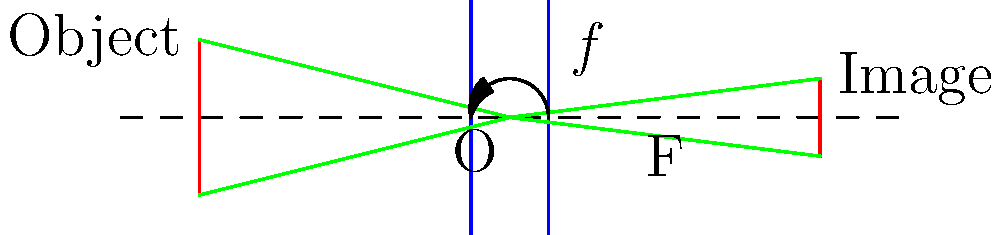As a film director, you're explaining to your cinematographer how a camera lens works. Using the diagram above, which represents a simplified camera lens system, calculate the focal length of the lens if the object distance is 4 units and the image distance is 4 units. How does this relate to the concept of a "50mm lens" in filmmaking? Let's approach this step-by-step:

1) In optics, we use the thin lens equation to relate object distance ($d_o$), image distance ($d_i$), and focal length ($f$):

   $$\frac{1}{f} = \frac{1}{d_o} + \frac{1}{d_i}$$

2) We're given that both object distance and image distance are 4 units:
   $d_o = 4$ and $d_i = 4$

3) Substituting these values into the thin lens equation:

   $$\frac{1}{f} = \frac{1}{4} + \frac{1}{4} = \frac{1}{2} + \frac{1}{2} = \frac{2}{2} = 1$$

4) Therefore, $f = 1$ unit

5) In filmmaking, a "50mm lens" refers to the focal length of the lens. While our calculation gives a focal length of 1 unit, in real cameras, this would be measured in millimeters. 

6) The 50mm lens is often called a "normal" lens because it approximates the perspective of human vision on a full-frame camera. It's a popular choice for filmmakers because it produces natural-looking images without noticeable distortion.

7) In our simplified model, the 1:1 ratio between object and image distance (both 4 units) results in an image the same size as the object. This is similar to how a 50mm lens on a full-frame camera approximates the size and perspective of human vision.
Answer: 1 unit (equivalent to 50mm in real cameras) 